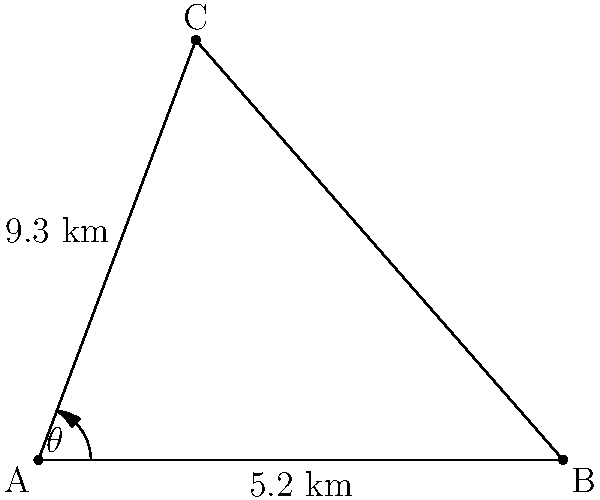Two rural polling stations (B and C) need to be connected for efficient vote counting. A surveyor at point A can see both stations. The distance from A to B is 5.2 km, and from A to C is 9.3 km. The angle $\theta$ between AB and AC is measured to be 69.4°. Calculate the distance between the two polling stations (BC) to determine the resources needed for establishing a direct communication link. To solve this problem, we'll use the law of cosines, which is ideal for triangles where we know two sides and the included angle.

1) The law of cosines states: $c^2 = a^2 + b^2 - 2ab \cos(C)$

2) In our case:
   $a = 5.2$ km (AB)
   $b = 9.3$ km (AC)
   $C = 69.4°$ (angle $\theta$)
   $c$ = BC (the distance we're solving for)

3) Plugging these values into the formula:
   $c^2 = 5.2^2 + 9.3^2 - 2(5.2)(9.3) \cos(69.4°)$

4) Simplify:
   $c^2 = 27.04 + 86.49 - 96.72 \cos(69.4°)$

5) Calculate $\cos(69.4°) \approx 0.3508$

6) Substitute:
   $c^2 = 27.04 + 86.49 - 96.72(0.3508)$
   $c^2 = 113.53 - 33.93$
   $c^2 = 79.60$

7) Take the square root of both sides:
   $c = \sqrt{79.60} \approx 8.92$

Therefore, the distance between the two polling stations is approximately 8.92 km.
Answer: 8.92 km 